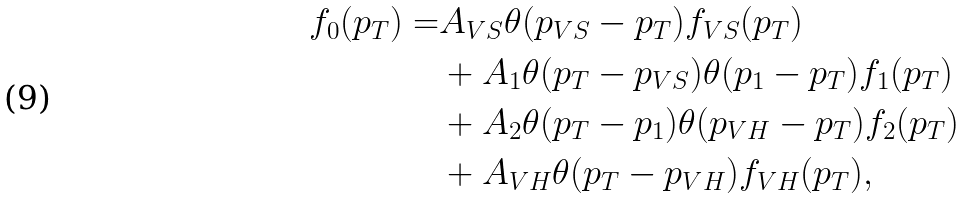<formula> <loc_0><loc_0><loc_500><loc_500>f _ { 0 } ( p _ { T } ) = & A _ { V S } \theta ( p _ { V S } - p _ { T } ) f _ { V S } ( p _ { T } ) \\ & + A _ { 1 } \theta ( p _ { T } - p _ { V S } ) \theta ( p _ { 1 } - p _ { T } ) f _ { 1 } ( p _ { T } ) \\ & + A _ { 2 } \theta ( p _ { T } - p _ { 1 } ) \theta ( p _ { V H } - p _ { T } ) f _ { 2 } ( p _ { T } ) \\ & + A _ { V H } \theta ( p _ { T } - p _ { V H } ) f _ { V H } ( p _ { T } ) ,</formula> 